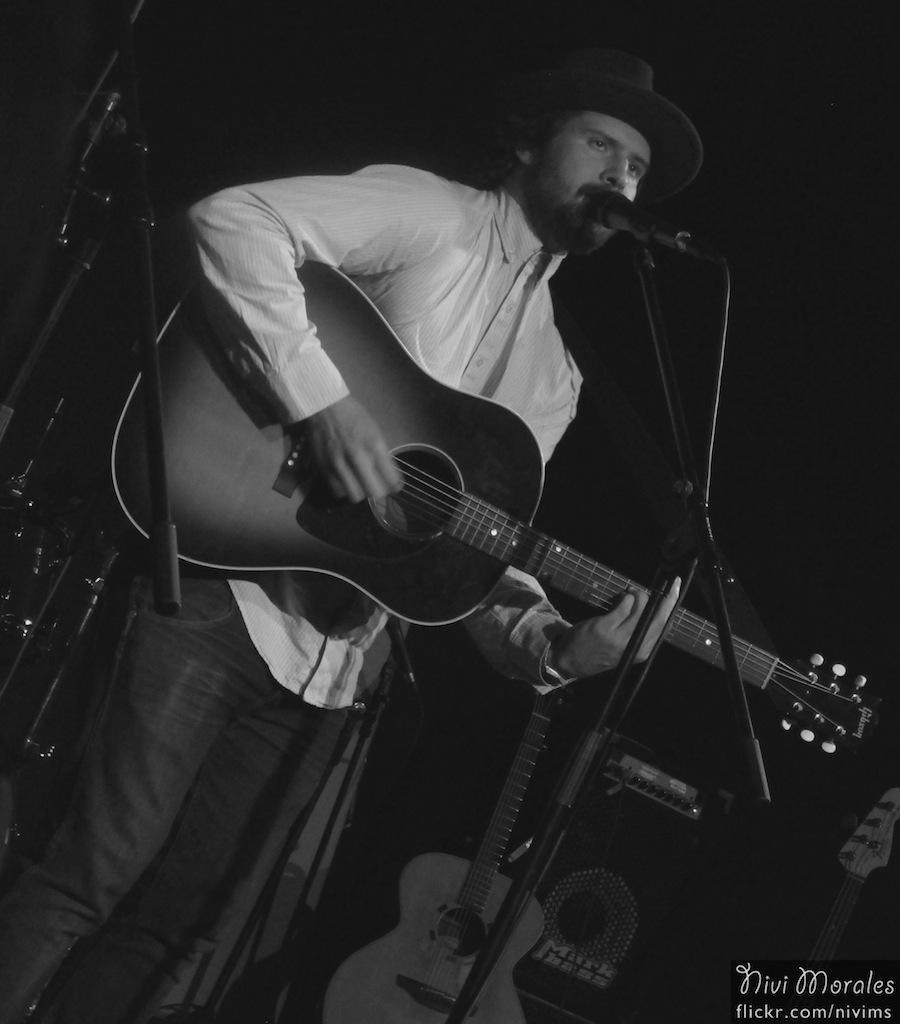What is the man in the image doing? The man is singing and playing a guitar. What is the man positioned in front of in the image? The man is in front of a microphone. What can be seen in the background of the image? There are musical instruments in the background of the image. How many ladybugs can be seen crawling on the guitar in the image? There are no ladybugs present in the image; the man is playing a guitar without any visible insects. 